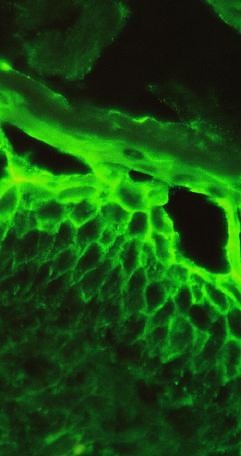re immunoglobulin deposits confined to superficial layers of the epidermis?
Answer the question using a single word or phrase. Yes 